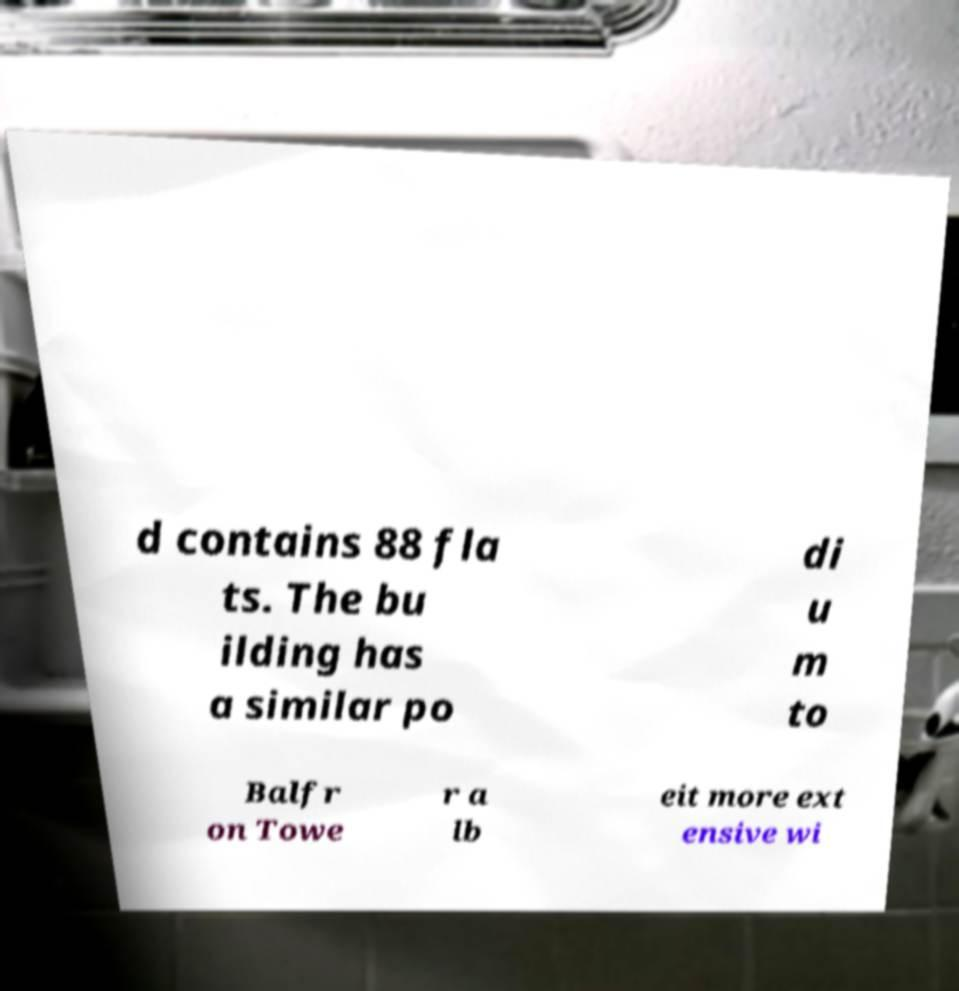I need the written content from this picture converted into text. Can you do that? d contains 88 fla ts. The bu ilding has a similar po di u m to Balfr on Towe r a lb eit more ext ensive wi 